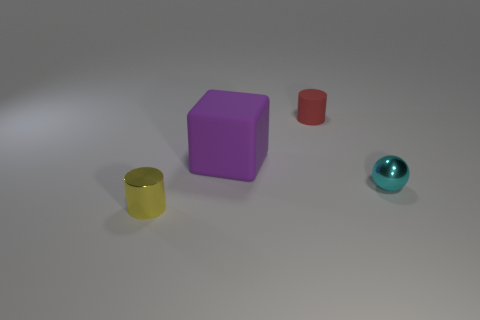Add 3 big green shiny spheres. How many objects exist? 7 Subtract all blocks. How many objects are left? 3 Add 2 yellow things. How many yellow things are left? 3 Add 2 small blue blocks. How many small blue blocks exist? 2 Subtract 0 blue balls. How many objects are left? 4 Subtract all large objects. Subtract all yellow things. How many objects are left? 2 